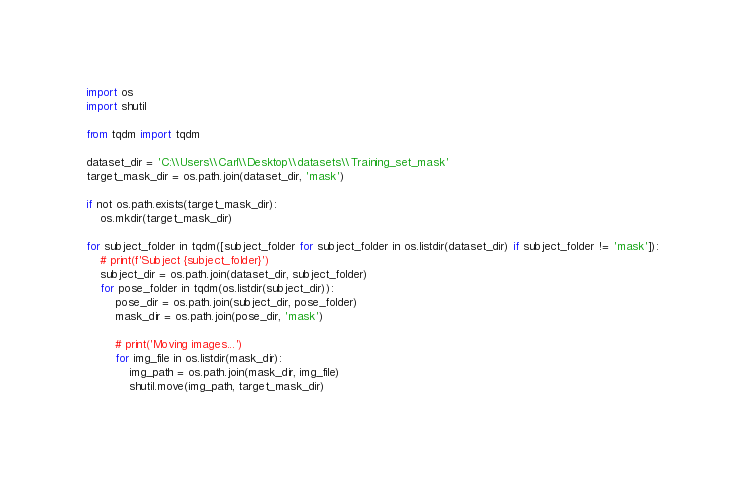Convert code to text. <code><loc_0><loc_0><loc_500><loc_500><_Python_>import os
import shutil

from tqdm import tqdm

dataset_dir = 'C:\\Users\\Carl\\Desktop\\datasets\\Training_set_mask'
target_mask_dir = os.path.join(dataset_dir, 'mask')

if not os.path.exists(target_mask_dir):
    os.mkdir(target_mask_dir)

for subject_folder in tqdm([subject_folder for subject_folder in os.listdir(dataset_dir) if subject_folder != 'mask']):
    # print(f'Subject {subject_folder}')
    subject_dir = os.path.join(dataset_dir, subject_folder)
    for pose_folder in tqdm(os.listdir(subject_dir)):
        pose_dir = os.path.join(subject_dir, pose_folder)
        mask_dir = os.path.join(pose_dir, 'mask')

        # print('Moving images...')
        for img_file in os.listdir(mask_dir):
            img_path = os.path.join(mask_dir, img_file)
            shutil.move(img_path, target_mask_dir)
</code> 